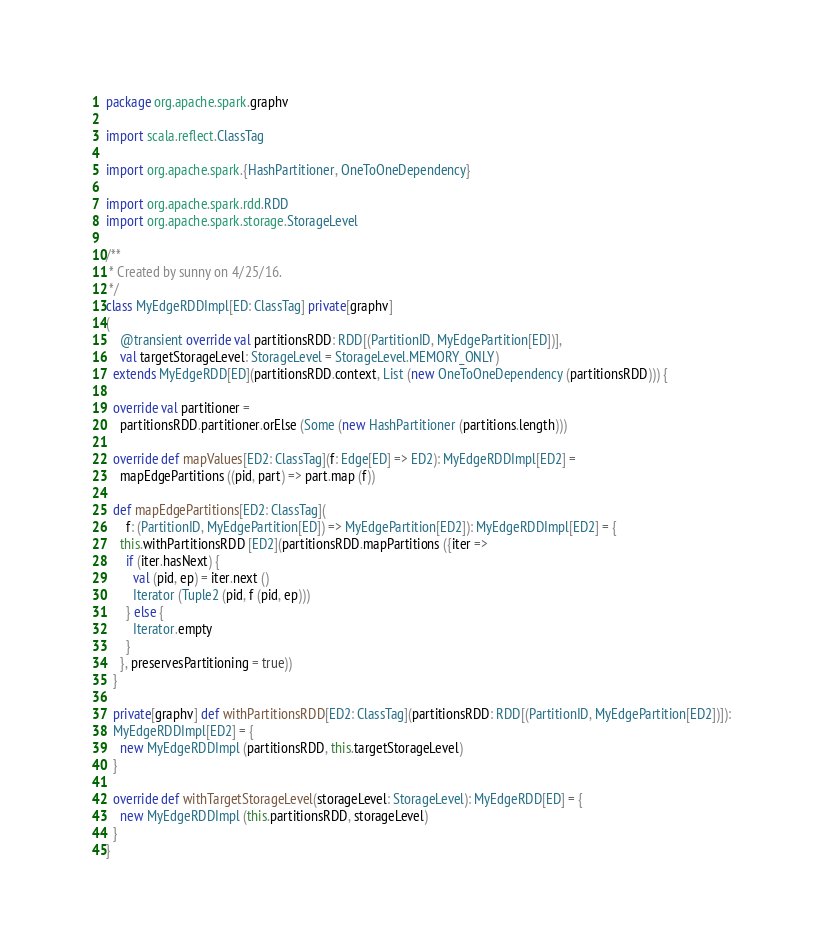<code> <loc_0><loc_0><loc_500><loc_500><_Scala_>package org.apache.spark.graphv

import scala.reflect.ClassTag

import org.apache.spark.{HashPartitioner, OneToOneDependency}

import org.apache.spark.rdd.RDD
import org.apache.spark.storage.StorageLevel

/**
 * Created by sunny on 4/25/16.
 */
class MyEdgeRDDImpl[ED: ClassTag] private[graphv]
(
    @transient override val partitionsRDD: RDD[(PartitionID, MyEdgePartition[ED])],
    val targetStorageLevel: StorageLevel = StorageLevel.MEMORY_ONLY)
  extends MyEdgeRDD[ED](partitionsRDD.context, List (new OneToOneDependency (partitionsRDD))) {

  override val partitioner =
    partitionsRDD.partitioner.orElse (Some (new HashPartitioner (partitions.length)))

  override def mapValues[ED2: ClassTag](f: Edge[ED] => ED2): MyEdgeRDDImpl[ED2] =
    mapEdgePartitions ((pid, part) => part.map (f))

  def mapEdgePartitions[ED2: ClassTag](
      f: (PartitionID, MyEdgePartition[ED]) => MyEdgePartition[ED2]): MyEdgeRDDImpl[ED2] = {
    this.withPartitionsRDD [ED2](partitionsRDD.mapPartitions ({iter =>
      if (iter.hasNext) {
        val (pid, ep) = iter.next ()
        Iterator (Tuple2 (pid, f (pid, ep)))
      } else {
        Iterator.empty
      }
    }, preservesPartitioning = true))
  }

  private[graphv] def withPartitionsRDD[ED2: ClassTag](partitionsRDD: RDD[(PartitionID, MyEdgePartition[ED2])]):
  MyEdgeRDDImpl[ED2] = {
    new MyEdgeRDDImpl (partitionsRDD, this.targetStorageLevel)
  }

  override def withTargetStorageLevel(storageLevel: StorageLevel): MyEdgeRDD[ED] = {
    new MyEdgeRDDImpl (this.partitionsRDD, storageLevel)
  }
}
</code> 